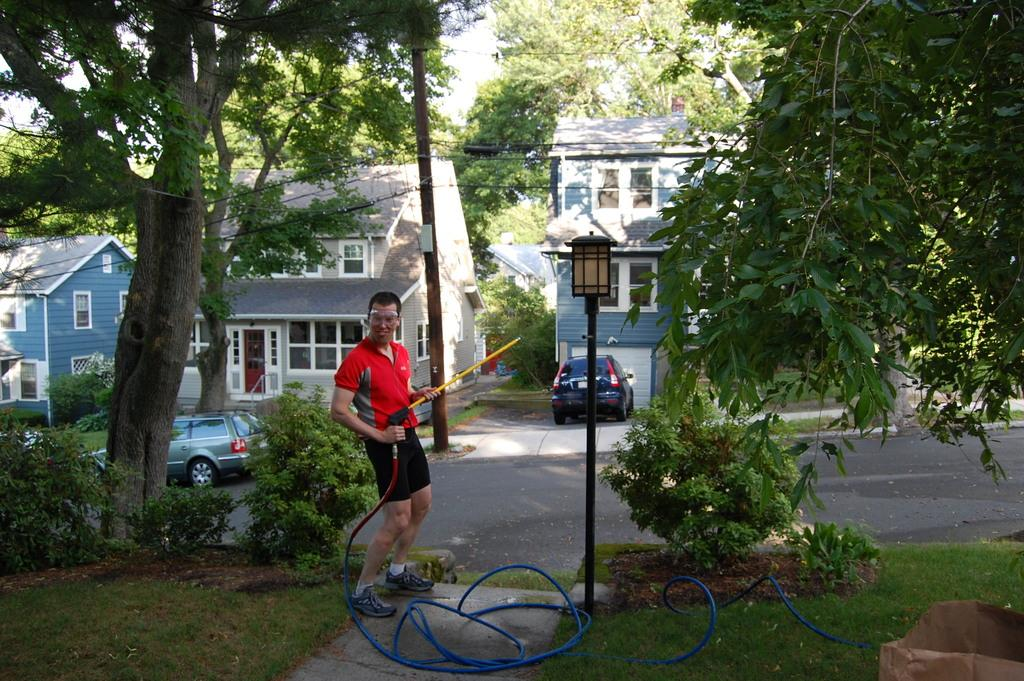What is the person in the image doing? The person is standing in the image and holding a pipe. What type of environment is depicted in the image? The image shows grass, plants, a road, cars, houses, trees, and the sky in the background. Can you describe the person's surroundings? The person is surrounded by grass, plants, a road, cars, houses, and trees. What is visible in the background of the image? The sky is visible in the background of the image. What current news event is the person discussing with the cars in the image? There is no indication of a news event or discussion in the image; it simply shows a person standing with a pipe, surrounded by various elements of the environment. 